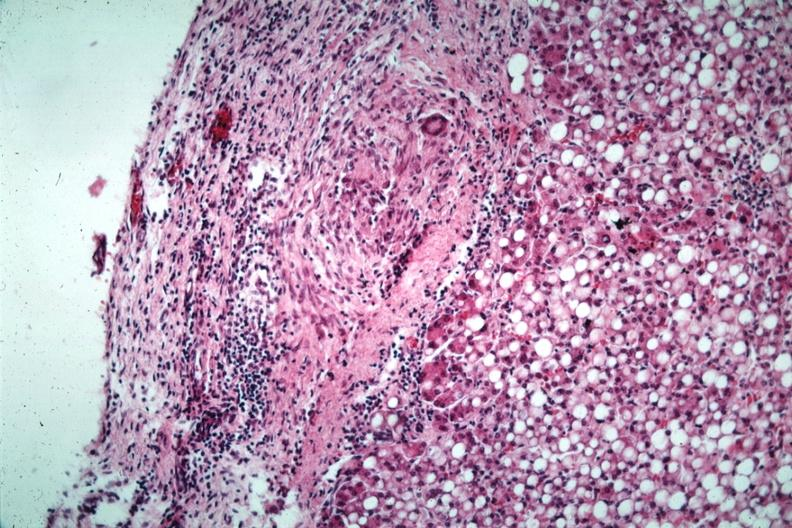has mesentery marked fatty change?
Answer the question using a single word or phrase. No 